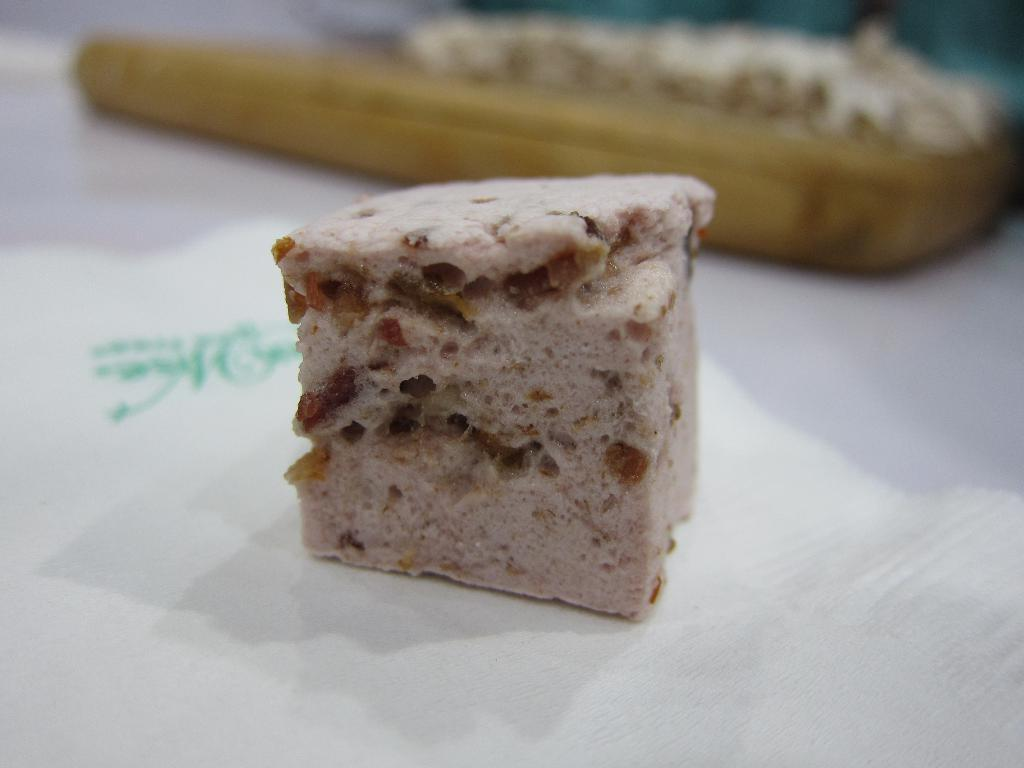What is the main subject in the middle of the image? There is a food item in the middle of the image. How is the food item placed in the image? The food item is placed on a tissue. Can you describe the background of the image? There is another food item visible in the background of the image. What type of garden can be seen in the image? There is no garden present in the image; it features a food item placed on a tissue with another food item visible in the background. 